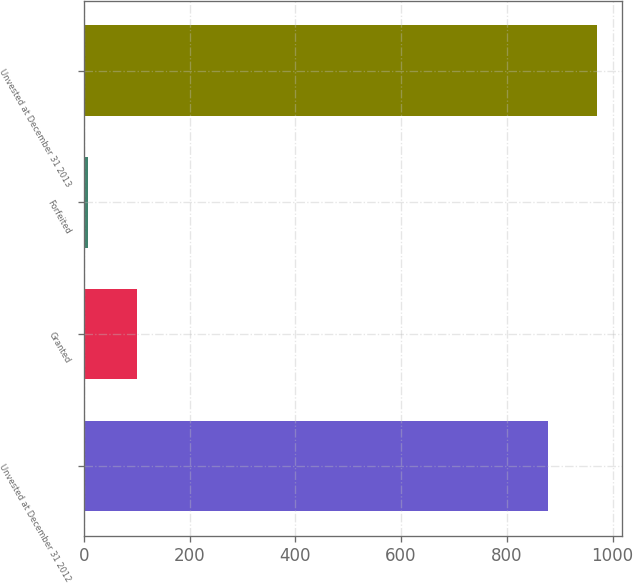Convert chart to OTSL. <chart><loc_0><loc_0><loc_500><loc_500><bar_chart><fcel>Unvested at December 31 2012<fcel>Granted<fcel>Forfeited<fcel>Unvested at December 31 2013<nl><fcel>878<fcel>99.7<fcel>8<fcel>969.7<nl></chart> 